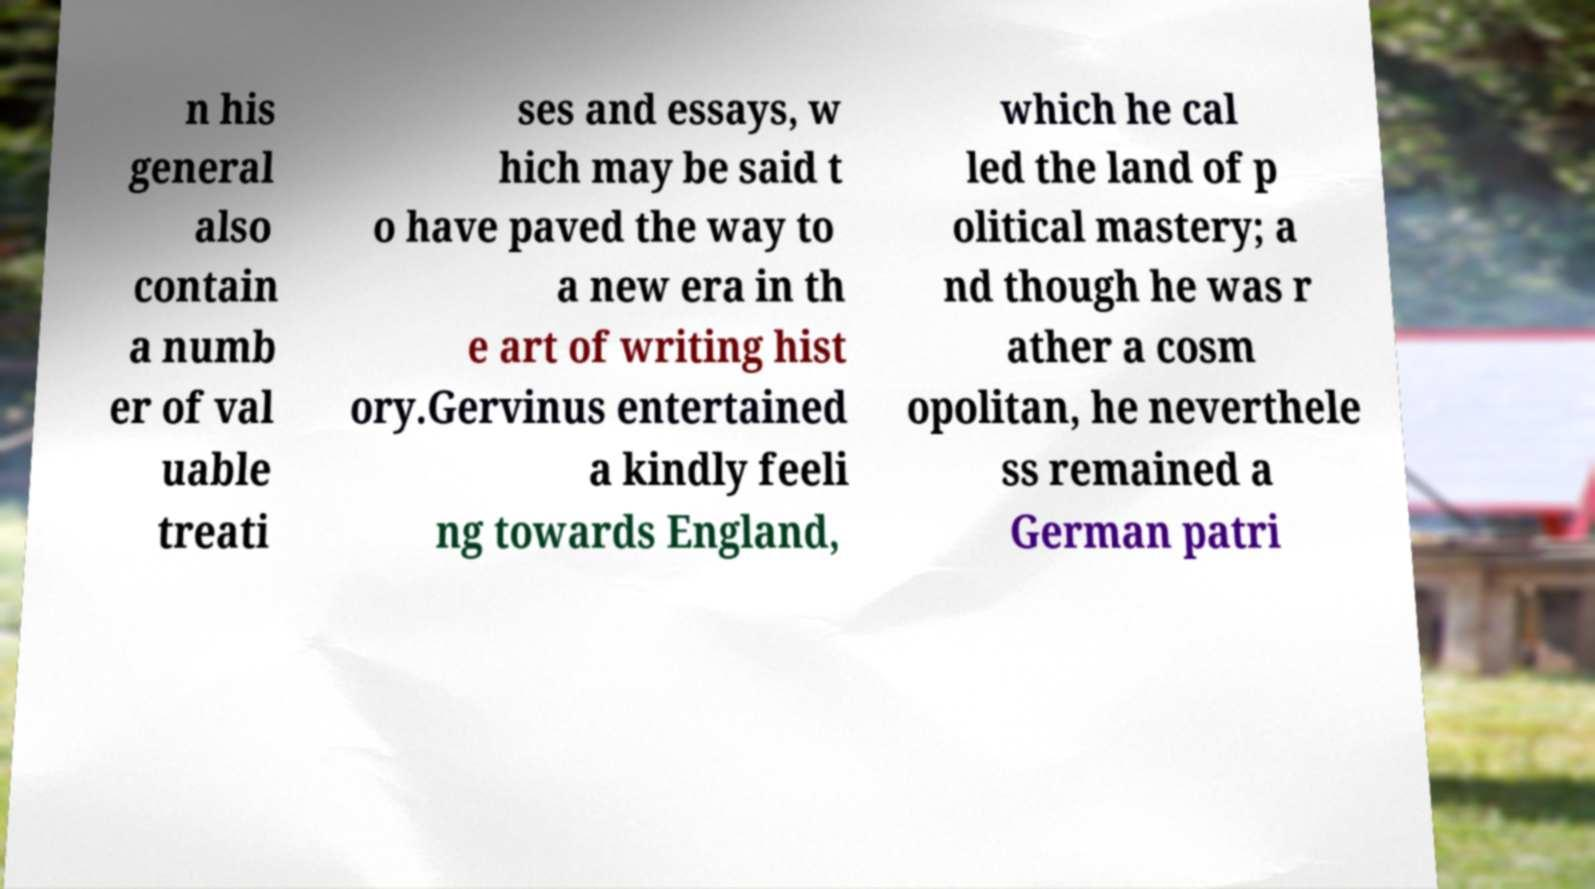What messages or text are displayed in this image? I need them in a readable, typed format. n his general also contain a numb er of val uable treati ses and essays, w hich may be said t o have paved the way to a new era in th e art of writing hist ory.Gervinus entertained a kindly feeli ng towards England, which he cal led the land of p olitical mastery; a nd though he was r ather a cosm opolitan, he neverthele ss remained a German patri 